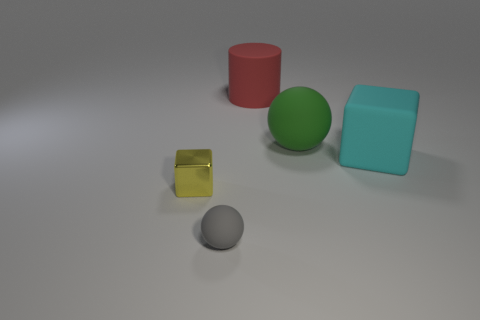Could you describe the lighting in the scene and how it affects the appearance of the objects? The lighting in the scene appears to be soft and diffused, coming from above as indicated by the gentle shadows under the objects. The softly illuminated setting highlights the true colors of the objects without harsh reflections, creating a calm and evenly lit composition. It contributes to a realistic representation of how the objects might look under natural lighting conditions. 